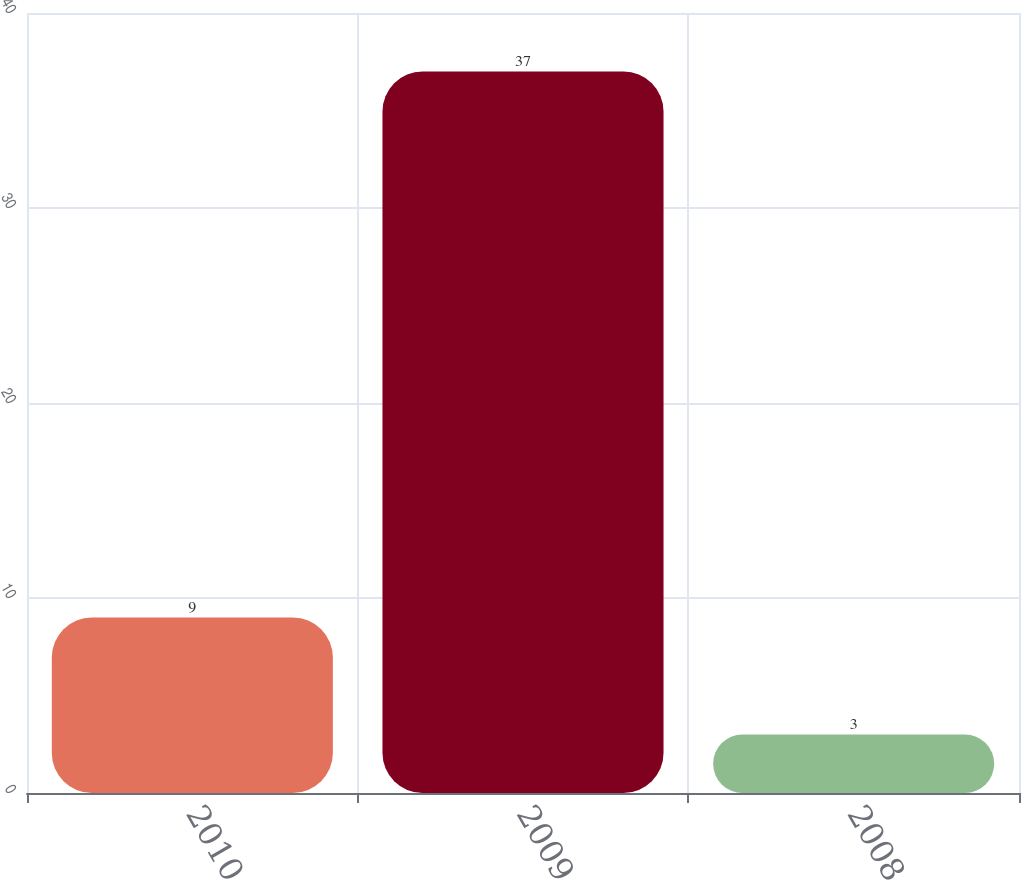Convert chart. <chart><loc_0><loc_0><loc_500><loc_500><bar_chart><fcel>2010<fcel>2009<fcel>2008<nl><fcel>9<fcel>37<fcel>3<nl></chart> 